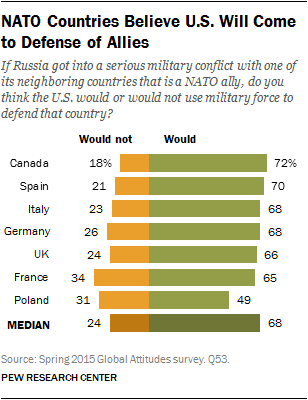Give some essential details in this illustration. According to the data, a median of 31% of respondents believe that the United States will not come to the defense of its allies in Poland, France, and the United Kingdom. According to a survey, only 0.68% of people believe that the United States will defend its allies in Italy. 